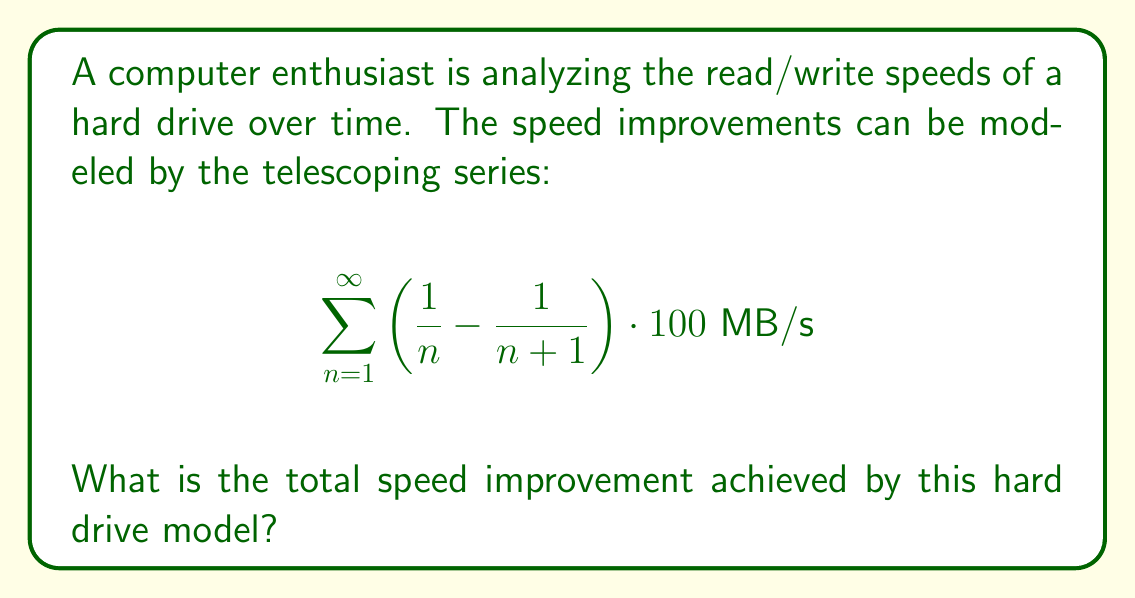Show me your answer to this math problem. Let's approach this step-by-step:

1) First, let's recognize the general form of this telescoping series:
   $$\sum_{n=1}^{\infty} \left(\frac{1}{n} - \frac{1}{n+1}\right)$$

2) In a telescoping series, most terms cancel out. Let's write out the first few terms:
   $$\left(\frac{1}{1} - \frac{1}{2}\right) + \left(\frac{1}{2} - \frac{1}{3}\right) + \left(\frac{1}{3} - \frac{1}{4}\right) + ...$$

3) We can see that all terms except the first and the limit of the last will cancel:
   $$\frac{1}{1} - \lim_{n \to \infty} \frac{1}{n+1}$$

4) As $n$ approaches infinity, $\frac{1}{n+1}$ approaches 0:
   $$\frac{1}{1} - 0 = 1$$

5) Now, remember that in our original series, this sum is multiplied by 100 MB/s:
   $$1 \cdot 100 \text{ MB/s} = 100 \text{ MB/s}$$

Therefore, the total speed improvement achieved by this hard drive model is 100 MB/s.
Answer: 100 MB/s 